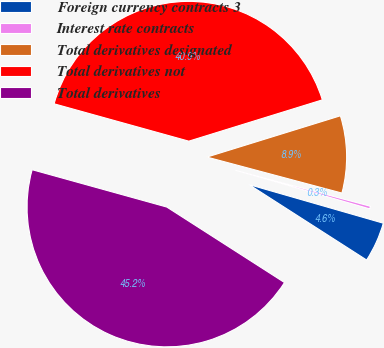<chart> <loc_0><loc_0><loc_500><loc_500><pie_chart><fcel>Foreign currency contracts 3<fcel>Interest rate contracts<fcel>Total derivatives designated<fcel>Total derivatives not<fcel>Total derivatives<nl><fcel>4.62%<fcel>0.31%<fcel>8.92%<fcel>40.92%<fcel>45.23%<nl></chart> 